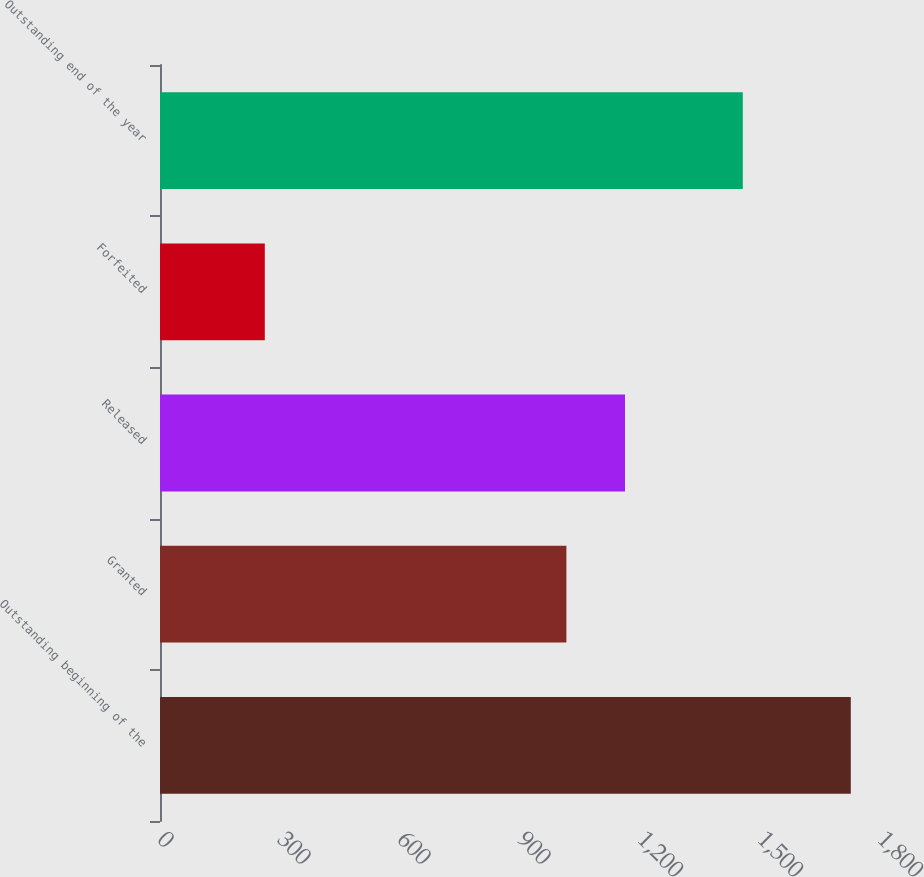Convert chart. <chart><loc_0><loc_0><loc_500><loc_500><bar_chart><fcel>Outstanding beginning of the<fcel>Granted<fcel>Released<fcel>Forfeited<fcel>Outstanding end of the year<nl><fcel>1727<fcel>1016<fcel>1162.5<fcel>262<fcel>1457<nl></chart> 